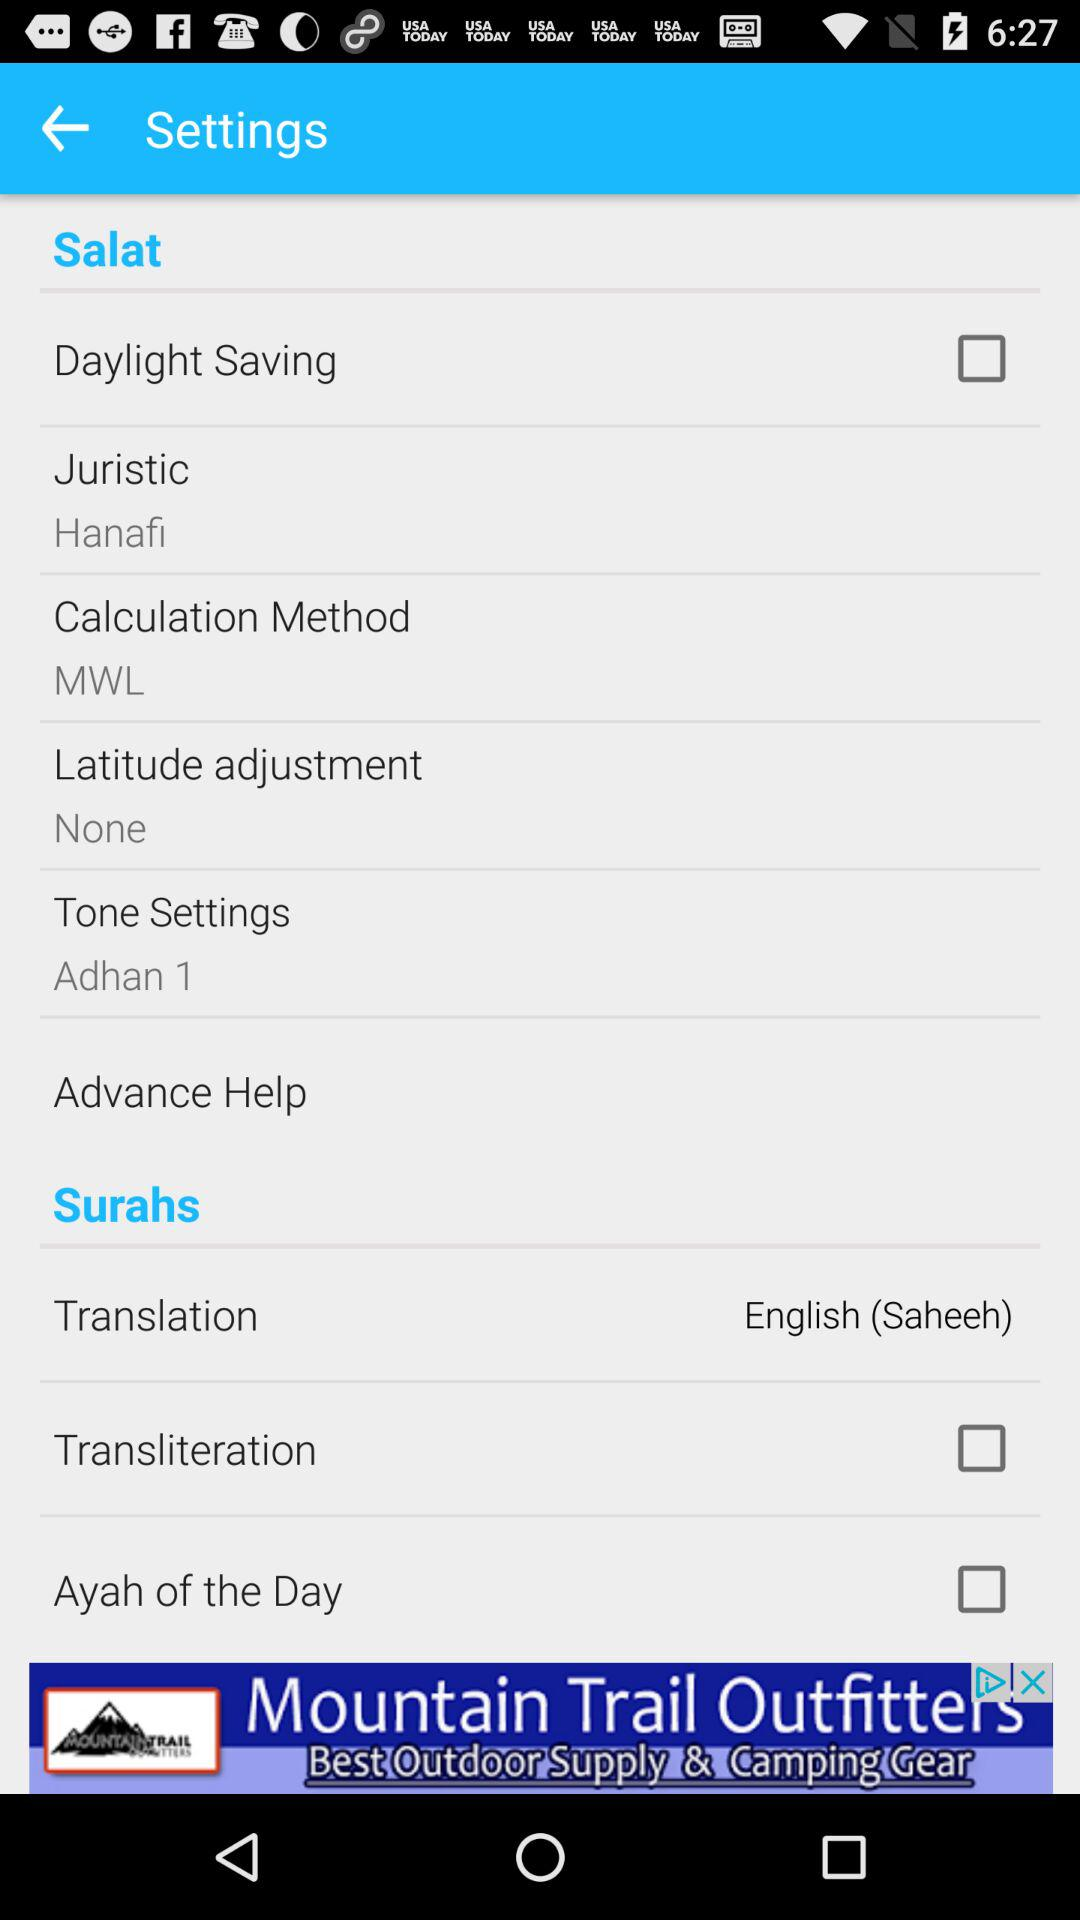Which tone is set in the tone settings? The set tone is "Adhan 1". 